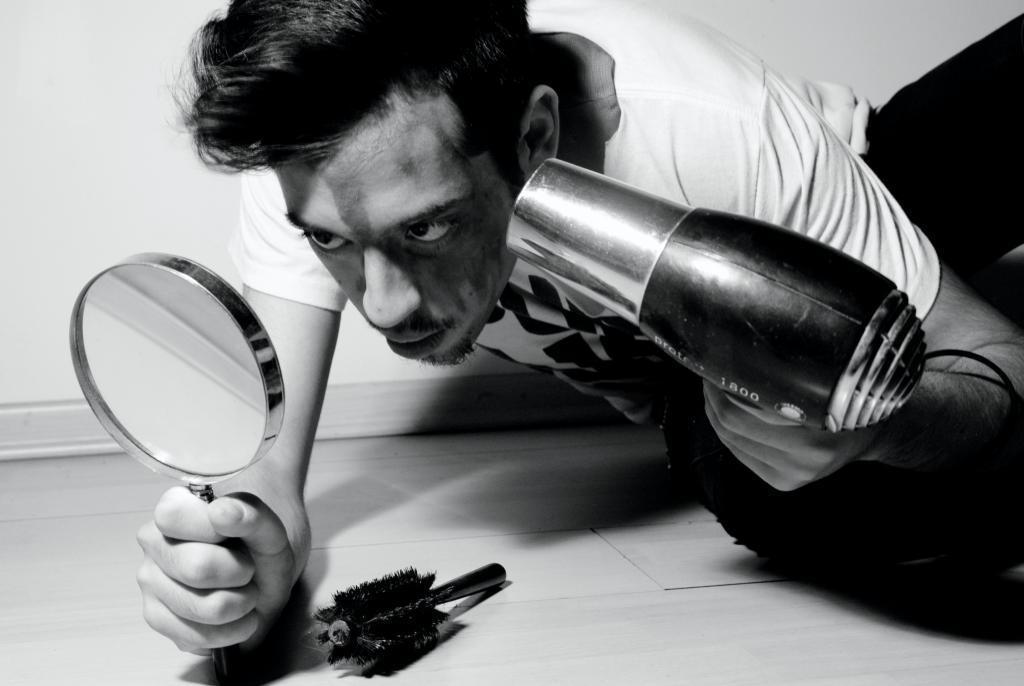Please provide a concise description of this image. This is a black and white image. In the center of the image we can see a man is bending and holding an object, dryer. At the bottom of the image we can see the floor and comb. At the top of the image we can see the wall. 